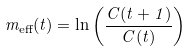<formula> <loc_0><loc_0><loc_500><loc_500>m _ { \text {eff} } ( t ) = \ln \left ( \frac { C ( t + 1 ) } { C ( t ) } \right )</formula> 